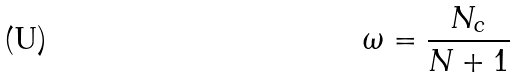Convert formula to latex. <formula><loc_0><loc_0><loc_500><loc_500>\omega = \frac { N _ { c } } { N + 1 }</formula> 